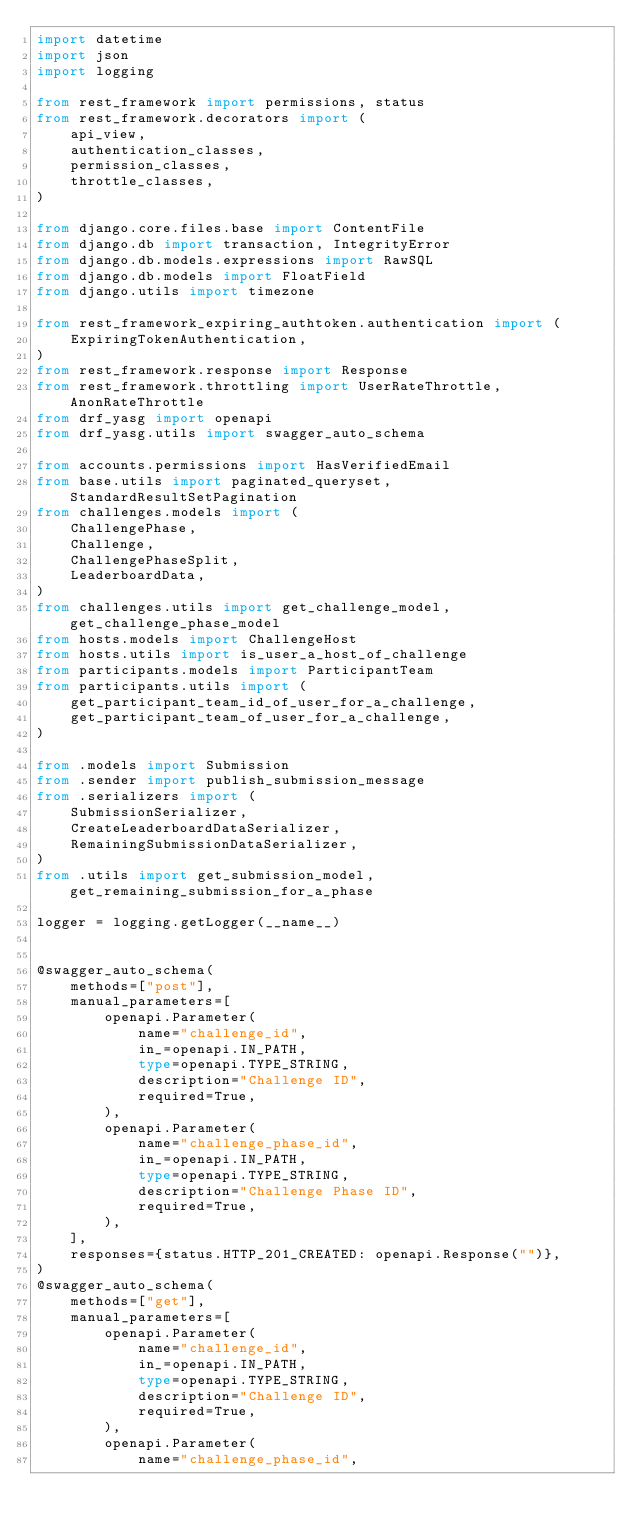<code> <loc_0><loc_0><loc_500><loc_500><_Python_>import datetime
import json
import logging

from rest_framework import permissions, status
from rest_framework.decorators import (
    api_view,
    authentication_classes,
    permission_classes,
    throttle_classes,
)

from django.core.files.base import ContentFile
from django.db import transaction, IntegrityError
from django.db.models.expressions import RawSQL
from django.db.models import FloatField
from django.utils import timezone

from rest_framework_expiring_authtoken.authentication import (
    ExpiringTokenAuthentication,
)
from rest_framework.response import Response
from rest_framework.throttling import UserRateThrottle, AnonRateThrottle
from drf_yasg import openapi
from drf_yasg.utils import swagger_auto_schema

from accounts.permissions import HasVerifiedEmail
from base.utils import paginated_queryset, StandardResultSetPagination
from challenges.models import (
    ChallengePhase,
    Challenge,
    ChallengePhaseSplit,
    LeaderboardData,
)
from challenges.utils import get_challenge_model, get_challenge_phase_model
from hosts.models import ChallengeHost
from hosts.utils import is_user_a_host_of_challenge
from participants.models import ParticipantTeam
from participants.utils import (
    get_participant_team_id_of_user_for_a_challenge,
    get_participant_team_of_user_for_a_challenge,
)

from .models import Submission
from .sender import publish_submission_message
from .serializers import (
    SubmissionSerializer,
    CreateLeaderboardDataSerializer,
    RemainingSubmissionDataSerializer,
)
from .utils import get_submission_model, get_remaining_submission_for_a_phase

logger = logging.getLogger(__name__)


@swagger_auto_schema(
    methods=["post"],
    manual_parameters=[
        openapi.Parameter(
            name="challenge_id",
            in_=openapi.IN_PATH,
            type=openapi.TYPE_STRING,
            description="Challenge ID",
            required=True,
        ),
        openapi.Parameter(
            name="challenge_phase_id",
            in_=openapi.IN_PATH,
            type=openapi.TYPE_STRING,
            description="Challenge Phase ID",
            required=True,
        ),
    ],
    responses={status.HTTP_201_CREATED: openapi.Response("")},
)
@swagger_auto_schema(
    methods=["get"],
    manual_parameters=[
        openapi.Parameter(
            name="challenge_id",
            in_=openapi.IN_PATH,
            type=openapi.TYPE_STRING,
            description="Challenge ID",
            required=True,
        ),
        openapi.Parameter(
            name="challenge_phase_id",</code> 